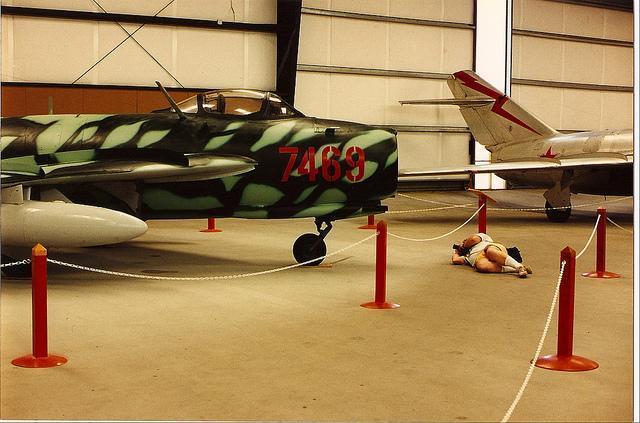How many airplanes are there?
Give a very brief answer. 2. 